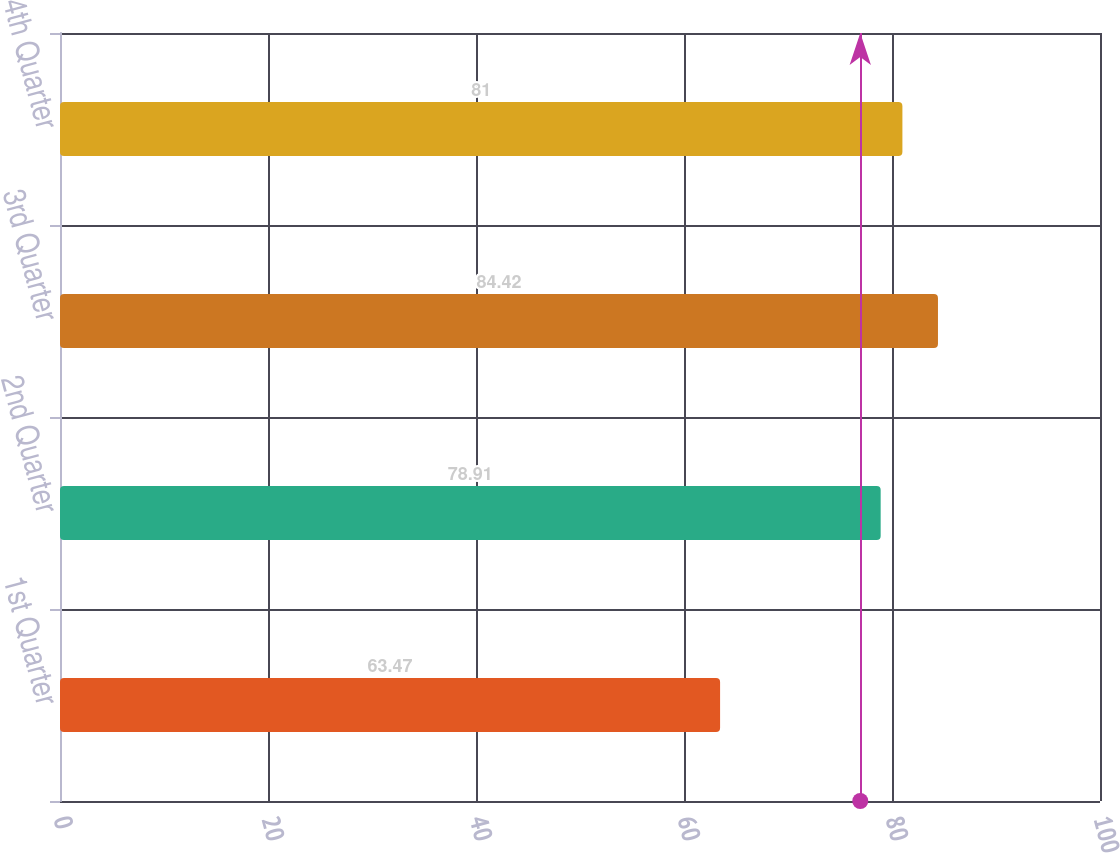Convert chart to OTSL. <chart><loc_0><loc_0><loc_500><loc_500><bar_chart><fcel>1st Quarter<fcel>2nd Quarter<fcel>3rd Quarter<fcel>4th Quarter<nl><fcel>63.47<fcel>78.91<fcel>84.42<fcel>81<nl></chart> 